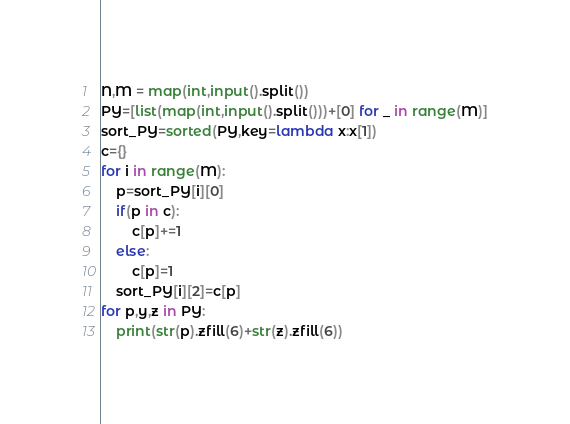<code> <loc_0><loc_0><loc_500><loc_500><_Python_>N,M = map(int,input().split())
PY=[list(map(int,input().split()))+[0] for _ in range(M)]
sort_PY=sorted(PY,key=lambda x:x[1])
c={}
for i in range(M):
    p=sort_PY[i][0]
    if(p in c):
        c[p]+=1
    else:
        c[p]=1
    sort_PY[i][2]=c[p]
for p,y,z in PY:
    print(str(p).zfill(6)+str(z).zfill(6))</code> 